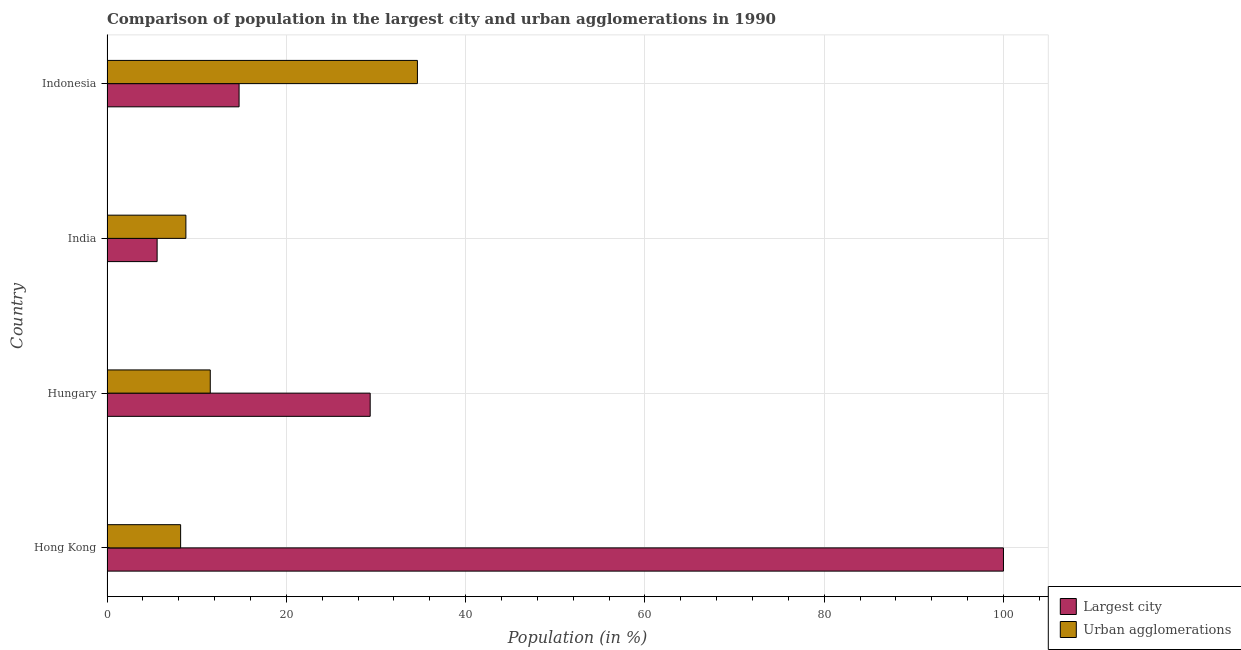How many different coloured bars are there?
Your answer should be compact. 2. How many bars are there on the 2nd tick from the top?
Offer a very short reply. 2. How many bars are there on the 1st tick from the bottom?
Ensure brevity in your answer.  2. What is the label of the 2nd group of bars from the top?
Offer a very short reply. India. What is the population in urban agglomerations in Indonesia?
Offer a very short reply. 34.63. Across all countries, what is the maximum population in the largest city?
Provide a succinct answer. 100. Across all countries, what is the minimum population in urban agglomerations?
Offer a terse response. 8.21. In which country was the population in the largest city maximum?
Your answer should be compact. Hong Kong. What is the total population in urban agglomerations in the graph?
Ensure brevity in your answer.  63.16. What is the difference between the population in the largest city in Hungary and that in India?
Give a very brief answer. 23.77. What is the difference between the population in urban agglomerations in Indonesia and the population in the largest city in India?
Give a very brief answer. 29.04. What is the average population in the largest city per country?
Make the answer very short. 37.42. What is the difference between the population in the largest city and population in urban agglomerations in Hungary?
Your response must be concise. 17.84. What is the ratio of the population in urban agglomerations in Hungary to that in Indonesia?
Provide a succinct answer. 0.33. What is the difference between the highest and the second highest population in the largest city?
Offer a terse response. 70.64. What is the difference between the highest and the lowest population in the largest city?
Offer a terse response. 94.41. Is the sum of the population in the largest city in Hungary and Indonesia greater than the maximum population in urban agglomerations across all countries?
Keep it short and to the point. Yes. What does the 2nd bar from the top in Hungary represents?
Your answer should be very brief. Largest city. What does the 1st bar from the bottom in India represents?
Your answer should be compact. Largest city. Are all the bars in the graph horizontal?
Keep it short and to the point. Yes. What is the difference between two consecutive major ticks on the X-axis?
Offer a terse response. 20. Does the graph contain any zero values?
Your answer should be very brief. No. Does the graph contain grids?
Your response must be concise. Yes. What is the title of the graph?
Provide a succinct answer. Comparison of population in the largest city and urban agglomerations in 1990. Does "Foreign Liabilities" appear as one of the legend labels in the graph?
Give a very brief answer. No. What is the label or title of the X-axis?
Keep it short and to the point. Population (in %). What is the label or title of the Y-axis?
Offer a terse response. Country. What is the Population (in %) in Largest city in Hong Kong?
Ensure brevity in your answer.  100. What is the Population (in %) in Urban agglomerations in Hong Kong?
Keep it short and to the point. 8.21. What is the Population (in %) of Largest city in Hungary?
Make the answer very short. 29.36. What is the Population (in %) in Urban agglomerations in Hungary?
Ensure brevity in your answer.  11.52. What is the Population (in %) in Largest city in India?
Offer a terse response. 5.59. What is the Population (in %) in Urban agglomerations in India?
Keep it short and to the point. 8.8. What is the Population (in %) of Largest city in Indonesia?
Ensure brevity in your answer.  14.73. What is the Population (in %) of Urban agglomerations in Indonesia?
Your answer should be very brief. 34.63. Across all countries, what is the maximum Population (in %) in Largest city?
Provide a succinct answer. 100. Across all countries, what is the maximum Population (in %) of Urban agglomerations?
Your response must be concise. 34.63. Across all countries, what is the minimum Population (in %) in Largest city?
Provide a succinct answer. 5.59. Across all countries, what is the minimum Population (in %) in Urban agglomerations?
Make the answer very short. 8.21. What is the total Population (in %) of Largest city in the graph?
Give a very brief answer. 149.68. What is the total Population (in %) of Urban agglomerations in the graph?
Keep it short and to the point. 63.16. What is the difference between the Population (in %) in Largest city in Hong Kong and that in Hungary?
Provide a succinct answer. 70.64. What is the difference between the Population (in %) of Urban agglomerations in Hong Kong and that in Hungary?
Provide a succinct answer. -3.31. What is the difference between the Population (in %) in Largest city in Hong Kong and that in India?
Your response must be concise. 94.41. What is the difference between the Population (in %) in Urban agglomerations in Hong Kong and that in India?
Your response must be concise. -0.59. What is the difference between the Population (in %) in Largest city in Hong Kong and that in Indonesia?
Offer a terse response. 85.27. What is the difference between the Population (in %) in Urban agglomerations in Hong Kong and that in Indonesia?
Ensure brevity in your answer.  -26.42. What is the difference between the Population (in %) of Largest city in Hungary and that in India?
Your answer should be compact. 23.77. What is the difference between the Population (in %) in Urban agglomerations in Hungary and that in India?
Your answer should be very brief. 2.72. What is the difference between the Population (in %) of Largest city in Hungary and that in Indonesia?
Keep it short and to the point. 14.63. What is the difference between the Population (in %) in Urban agglomerations in Hungary and that in Indonesia?
Provide a short and direct response. -23.11. What is the difference between the Population (in %) in Largest city in India and that in Indonesia?
Ensure brevity in your answer.  -9.14. What is the difference between the Population (in %) of Urban agglomerations in India and that in Indonesia?
Offer a terse response. -25.83. What is the difference between the Population (in %) in Largest city in Hong Kong and the Population (in %) in Urban agglomerations in Hungary?
Your answer should be compact. 88.48. What is the difference between the Population (in %) of Largest city in Hong Kong and the Population (in %) of Urban agglomerations in India?
Your answer should be very brief. 91.2. What is the difference between the Population (in %) of Largest city in Hong Kong and the Population (in %) of Urban agglomerations in Indonesia?
Provide a short and direct response. 65.37. What is the difference between the Population (in %) of Largest city in Hungary and the Population (in %) of Urban agglomerations in India?
Offer a very short reply. 20.56. What is the difference between the Population (in %) of Largest city in Hungary and the Population (in %) of Urban agglomerations in Indonesia?
Give a very brief answer. -5.27. What is the difference between the Population (in %) of Largest city in India and the Population (in %) of Urban agglomerations in Indonesia?
Keep it short and to the point. -29.04. What is the average Population (in %) of Largest city per country?
Keep it short and to the point. 37.42. What is the average Population (in %) in Urban agglomerations per country?
Provide a short and direct response. 15.79. What is the difference between the Population (in %) in Largest city and Population (in %) in Urban agglomerations in Hong Kong?
Make the answer very short. 91.79. What is the difference between the Population (in %) of Largest city and Population (in %) of Urban agglomerations in Hungary?
Provide a short and direct response. 17.84. What is the difference between the Population (in %) of Largest city and Population (in %) of Urban agglomerations in India?
Make the answer very short. -3.21. What is the difference between the Population (in %) of Largest city and Population (in %) of Urban agglomerations in Indonesia?
Ensure brevity in your answer.  -19.89. What is the ratio of the Population (in %) in Largest city in Hong Kong to that in Hungary?
Give a very brief answer. 3.41. What is the ratio of the Population (in %) of Urban agglomerations in Hong Kong to that in Hungary?
Offer a very short reply. 0.71. What is the ratio of the Population (in %) in Largest city in Hong Kong to that in India?
Your answer should be very brief. 17.88. What is the ratio of the Population (in %) in Urban agglomerations in Hong Kong to that in India?
Your answer should be compact. 0.93. What is the ratio of the Population (in %) in Largest city in Hong Kong to that in Indonesia?
Your answer should be very brief. 6.79. What is the ratio of the Population (in %) of Urban agglomerations in Hong Kong to that in Indonesia?
Offer a very short reply. 0.24. What is the ratio of the Population (in %) of Largest city in Hungary to that in India?
Your answer should be compact. 5.25. What is the ratio of the Population (in %) in Urban agglomerations in Hungary to that in India?
Offer a terse response. 1.31. What is the ratio of the Population (in %) in Largest city in Hungary to that in Indonesia?
Provide a succinct answer. 1.99. What is the ratio of the Population (in %) in Urban agglomerations in Hungary to that in Indonesia?
Offer a very short reply. 0.33. What is the ratio of the Population (in %) of Largest city in India to that in Indonesia?
Offer a terse response. 0.38. What is the ratio of the Population (in %) in Urban agglomerations in India to that in Indonesia?
Offer a very short reply. 0.25. What is the difference between the highest and the second highest Population (in %) in Largest city?
Keep it short and to the point. 70.64. What is the difference between the highest and the second highest Population (in %) in Urban agglomerations?
Provide a succinct answer. 23.11. What is the difference between the highest and the lowest Population (in %) of Largest city?
Your response must be concise. 94.41. What is the difference between the highest and the lowest Population (in %) in Urban agglomerations?
Your answer should be compact. 26.42. 